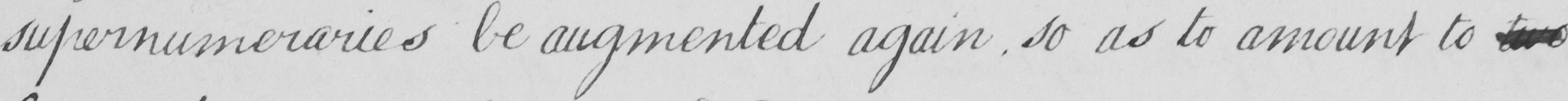Can you tell me what this handwritten text says? supernumeraries be augmented again , so as to amount to two 